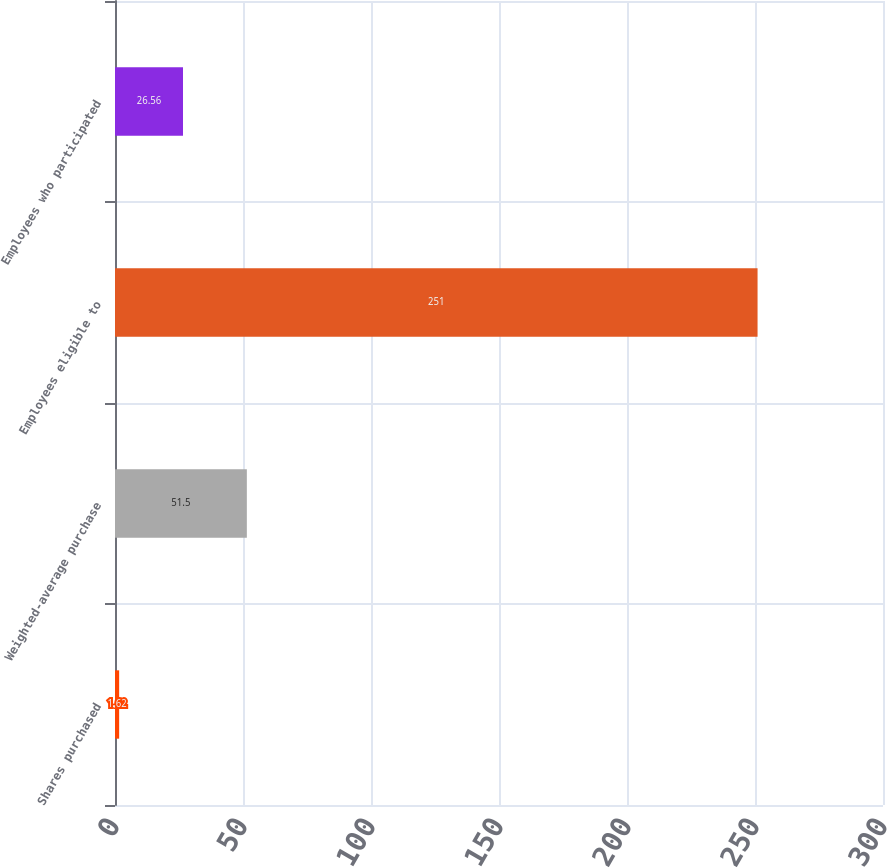Convert chart. <chart><loc_0><loc_0><loc_500><loc_500><bar_chart><fcel>Shares purchased<fcel>Weighted-average purchase<fcel>Employees eligible to<fcel>Employees who participated<nl><fcel>1.62<fcel>51.5<fcel>251<fcel>26.56<nl></chart> 